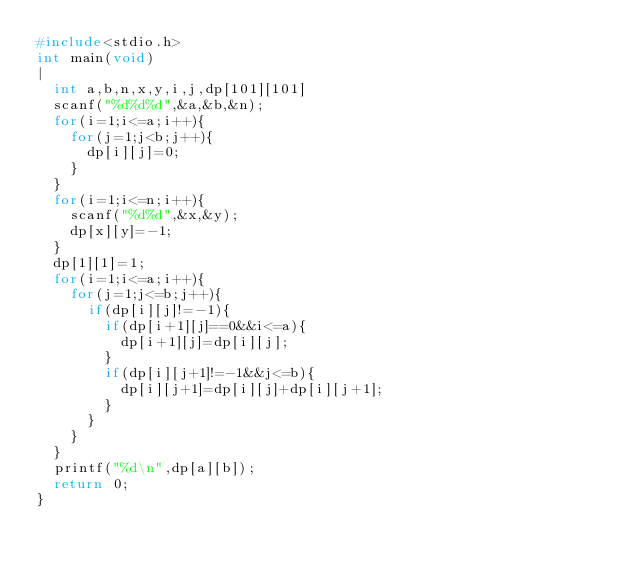Convert code to text. <code><loc_0><loc_0><loc_500><loc_500><_C++_>#include<stdio.h>
int main(void)
|
	int a,b,n,x,y,i,j,dp[101][101]
	scanf("%d%d%d",&a,&b,&n);
	for(i=1;i<=a;i++){
		for(j=1;j<b;j++){
			dp[i][j]=0;
		}
	}
	for(i=1;i<=n;i++){
		scanf("%d%d",&x,&y);
		dp[x][y]=-1;
	}
	dp[1][1]=1;
	for(i=1;i<=a;i++){
		for(j=1;j<=b;j++){
			if(dp[i][j]!=-1){
				if(dp[i+1][j]==0&&i<=a){
					dp[i+1][j]=dp[i][j];
				}
				if(dp[i][j+1]!=-1&&j<=b){
					dp[i][j+1]=dp[i][j]+dp[i][j+1];
				}
			}
		}
	}
	printf("%d\n",dp[a][b]);
	return 0;
}</code> 